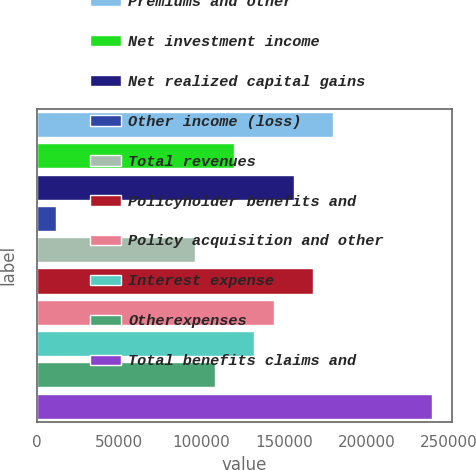Convert chart to OTSL. <chart><loc_0><loc_0><loc_500><loc_500><bar_chart><fcel>Premiums and other<fcel>Net investment income<fcel>Net realized capital gains<fcel>Other income (loss)<fcel>Total revenues<fcel>Policyholder benefits and<fcel>Policy acquisition and other<fcel>Interest expense<fcel>Otherexpenses<fcel>Total benefits claims and<nl><fcel>179779<fcel>119865<fcel>155813<fcel>12020.6<fcel>95899.6<fcel>167796<fcel>143830<fcel>131848<fcel>107882<fcel>239692<nl></chart> 